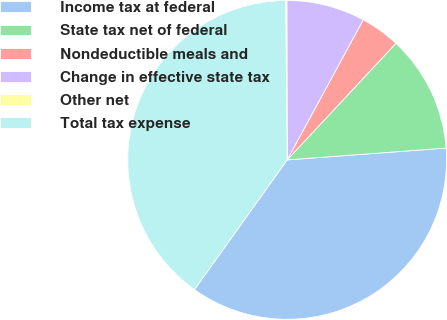<chart> <loc_0><loc_0><loc_500><loc_500><pie_chart><fcel>Income tax at federal<fcel>State tax net of federal<fcel>Nondeductible meals and<fcel>Change in effective state tax<fcel>Other net<fcel>Total tax expense<nl><fcel>36.06%<fcel>11.87%<fcel>4.03%<fcel>7.95%<fcel>0.11%<fcel>39.98%<nl></chart> 